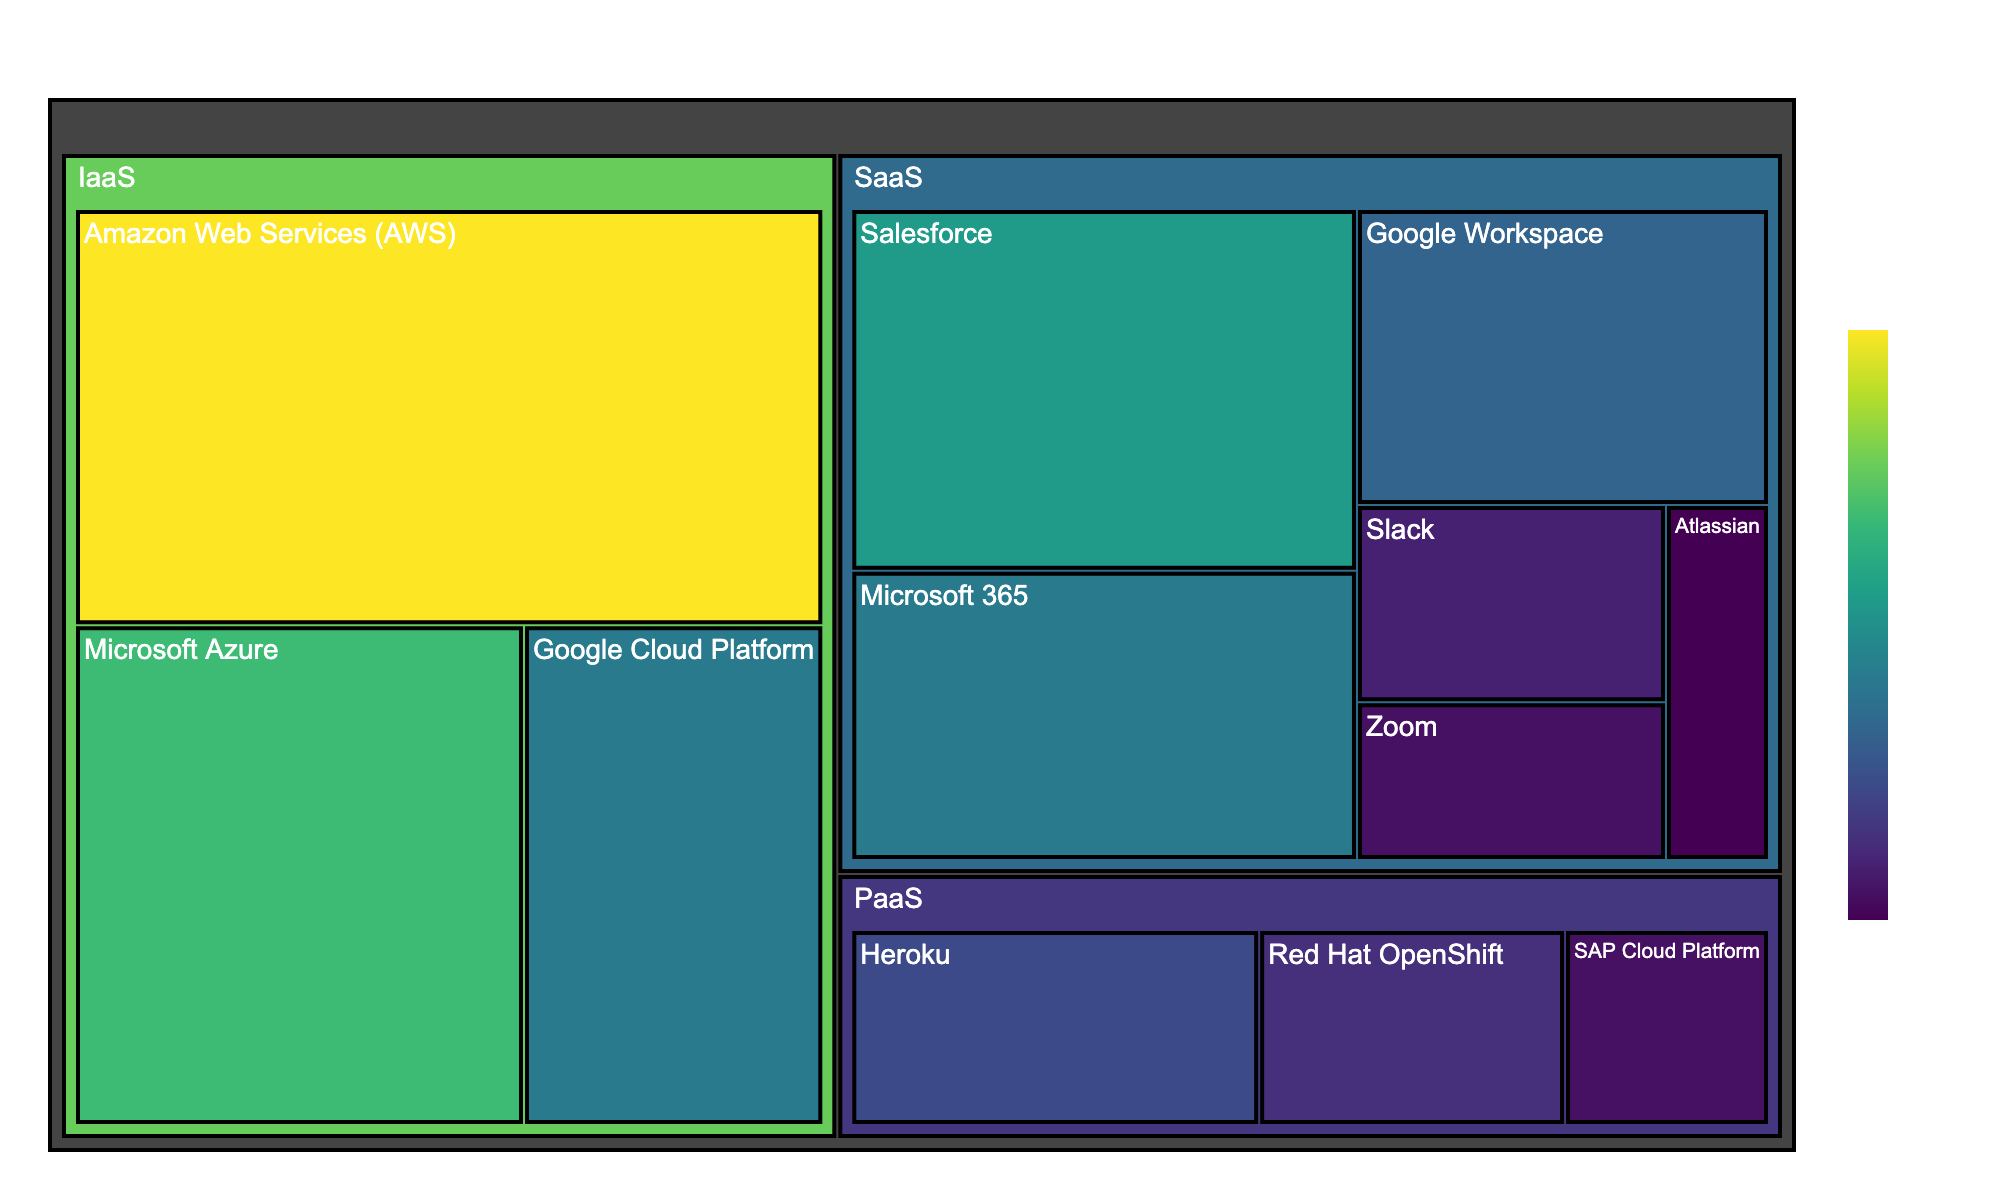What is the title of the figure? The title is usually displayed at the top of the figure. In this case, it is clearly stated as "Cloud Computing Services Usage Breakdown".
Answer: Cloud Computing Services Usage Breakdown Which cloud provider has the highest usage in the IaaS category? To determine this, look at the sector sizes in the IaaS category. The AWS sector is notably larger than the others, indicating higher usage.
Answer: Amazon Web Services (AWS) How many cloud providers are shown in the SaaS category? Count the number of distinct sectors under the SaaS category. The providers listed are Salesforce, Microsoft 365, Google Workspace, Slack, Zoom, and Atlassian, giving a total of 6 providers.
Answer: 6 What is the combined usage percentage for all PaaS providers? Sum the usage values of all PaaS providers: Heroku (8), Red Hat OpenShift (6), and SAP Cloud Platform (4). The total is 8 + 6 + 4 = 18.
Answer: 18 Which cloud provider has the lowest usage in the SaaS category? Look for the smallest sector in the SaaS category, which corresponds to Atlassian with a usage of 3.
Answer: Atlassian Compare the usage between AWS (IaaS) and Google Workspace (SaaS). Which one is higher? Locate the sectors for AWS under IaaS and Google Workspace under SaaS. AWS has a usage of 25, while Google Workspace has 10. Thus, AWS has higher usage.
Answer: AWS What percentage of total SaaS usage does Salesforce contribute? First, sum the usage of all SaaS providers: 15 (Salesforce) + 12 (Microsoft 365) + 10 (Google Workspace) + 5 (Slack) + 4 (Zoom) + 3 (Atlassian) = 49. Salesforce's percentage is (15 / 49) * 100.
Answer: 30.61% Is the total usage of Microsoft services (Azure + Microsoft 365) higher than that of Google services (Google Cloud Platform + Google Workspace)? Sum the usage of Microsoft services: Azure (18) + Microsoft 365 (12) = 30. Sum the usage of Google services: Google Cloud Platform (12) + Google Workspace (10) = 22. Thus, Microsoft's total is higher.
Answer: Yes Which category has the most diverse range of providers? Compare the number of distinct providers in each category: IaaS (AWS, Azure, Google Cloud Platform), PaaS (Heroku, Red Hat OpenShift, SAP Cloud Platform), and SaaS (Salesforce, Microsoft 365, Google Workspace, Slack, Zoom, Atlassian). The SaaS category has the most with 6 providers.
Answer: SaaS What is the difference in usage between the highest and lowest provider within the PaaS category? Identify the highest usage in PaaS (Heroku, 8) and the lowest usage (SAP Cloud Platform, 4). The difference is 8 - 4.
Answer: 4 